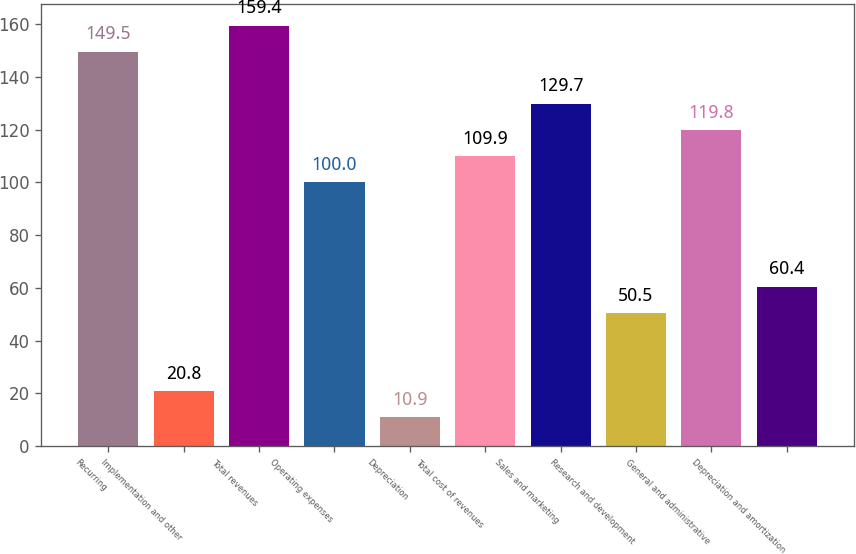Convert chart to OTSL. <chart><loc_0><loc_0><loc_500><loc_500><bar_chart><fcel>Recurring<fcel>Implementation and other<fcel>Total revenues<fcel>Operating expenses<fcel>Depreciation<fcel>Total cost of revenues<fcel>Sales and marketing<fcel>Research and development<fcel>General and administrative<fcel>Depreciation and amortization<nl><fcel>149.5<fcel>20.8<fcel>159.4<fcel>100<fcel>10.9<fcel>109.9<fcel>129.7<fcel>50.5<fcel>119.8<fcel>60.4<nl></chart> 